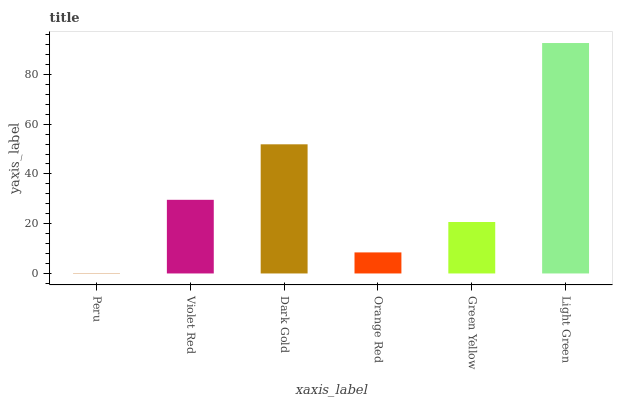Is Peru the minimum?
Answer yes or no. Yes. Is Light Green the maximum?
Answer yes or no. Yes. Is Violet Red the minimum?
Answer yes or no. No. Is Violet Red the maximum?
Answer yes or no. No. Is Violet Red greater than Peru?
Answer yes or no. Yes. Is Peru less than Violet Red?
Answer yes or no. Yes. Is Peru greater than Violet Red?
Answer yes or no. No. Is Violet Red less than Peru?
Answer yes or no. No. Is Violet Red the high median?
Answer yes or no. Yes. Is Green Yellow the low median?
Answer yes or no. Yes. Is Green Yellow the high median?
Answer yes or no. No. Is Light Green the low median?
Answer yes or no. No. 